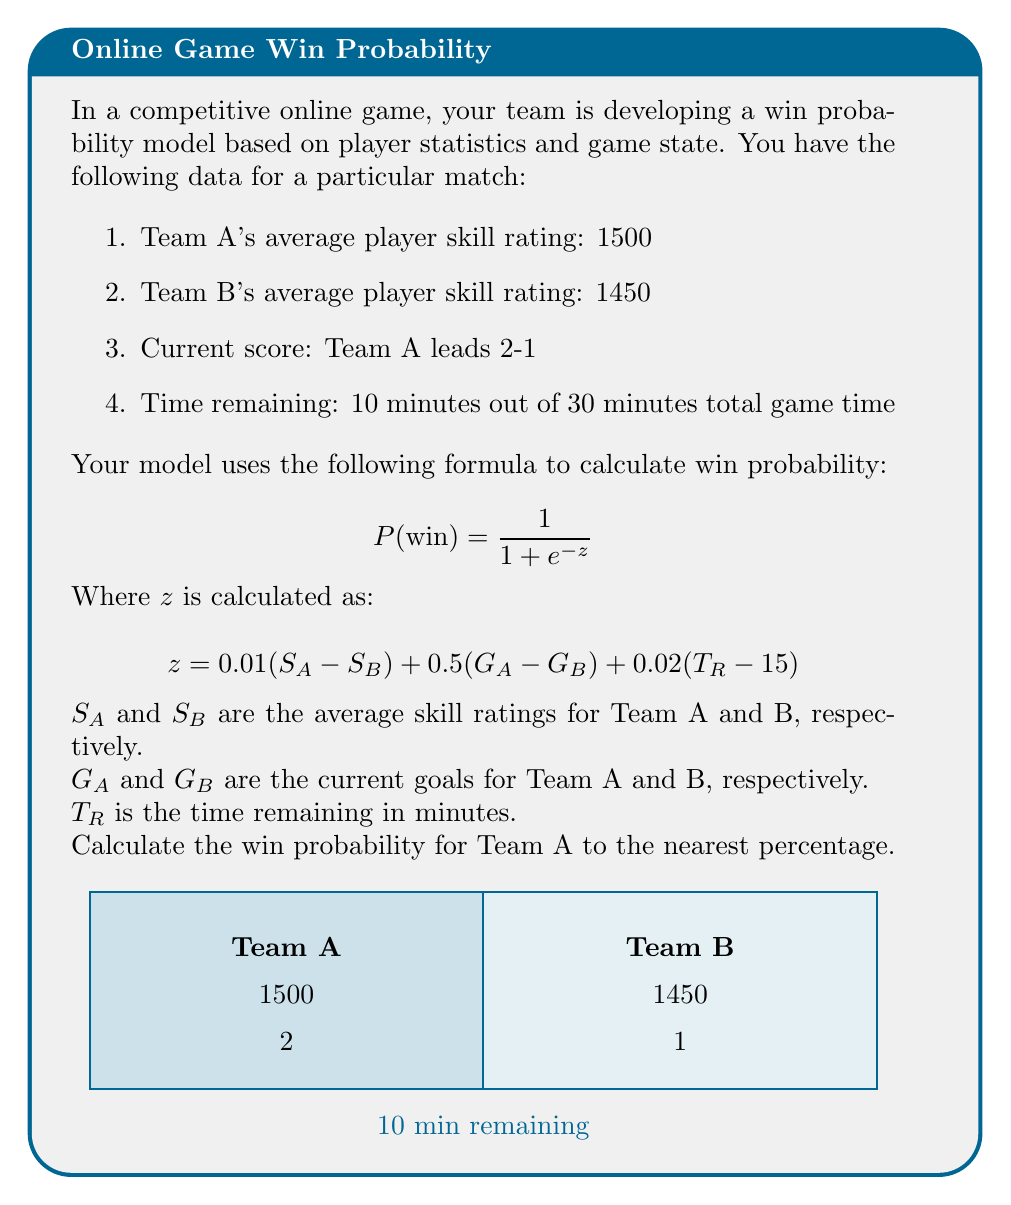Can you solve this math problem? Let's solve this step-by-step:

1) First, we need to calculate $z$ using the given formula:

   $$ z = 0.01(S_A - S_B) + 0.5(G_A - G_B) + 0.02(T_R - 15) $$

2) Substituting the values:
   $S_A = 1500$, $S_B = 1450$
   $G_A = 2$, $G_B = 1$
   $T_R = 10$

3) Calculating $z$:
   $$ z = 0.01(1500 - 1450) + 0.5(2 - 1) + 0.02(10 - 15) $$
   $$ z = 0.01(50) + 0.5(1) + 0.02(-5) $$
   $$ z = 0.5 + 0.5 - 0.1 $$
   $$ z = 0.9 $$

4) Now we can use this $z$ value in the win probability formula:

   $$ P(\text{win}) = \frac{1}{1 + e^{-z}} $$

5) Substituting $z = 0.9$:
   $$ P(\text{win}) = \frac{1}{1 + e^{-0.9}} $$

6) Using a calculator or computer to evaluate this:
   $$ P(\text{win}) \approx 0.7109 $$

7) Converting to a percentage and rounding to the nearest whole number:
   $0.7109 * 100 \approx 71\%$

Therefore, Team A's win probability is approximately 71%.
Answer: 71% 